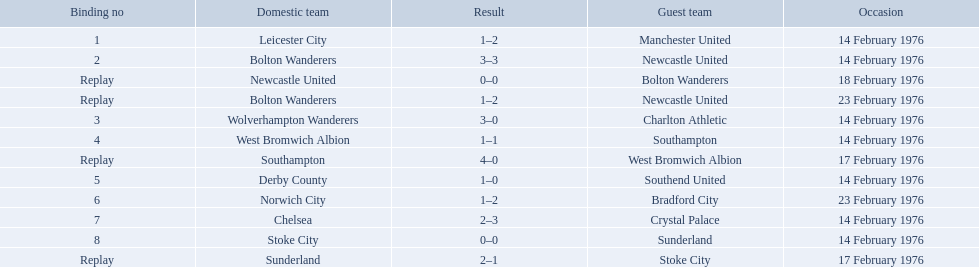What is the game at the top of the table? 1. Who is the home team for this game? Leicester City. What were the home teams in the 1975-76 fa cup? Leicester City, Bolton Wanderers, Newcastle United, Bolton Wanderers, Wolverhampton Wanderers, West Bromwich Albion, Southampton, Derby County, Norwich City, Chelsea, Stoke City, Sunderland. Which of these teams had the tie number 1? Leicester City. 